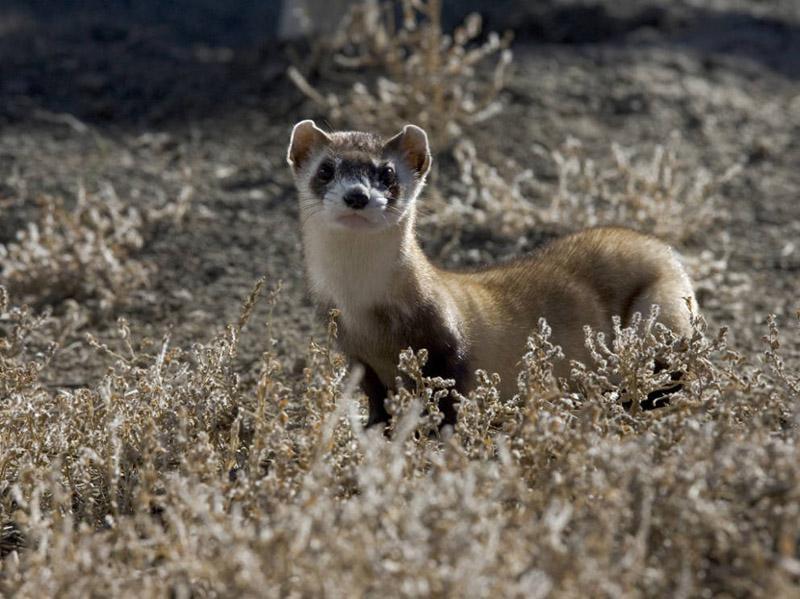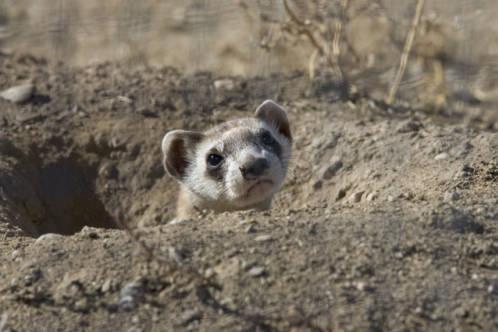The first image is the image on the left, the second image is the image on the right. Given the left and right images, does the statement "All bodies of the animals pictured are facing right." hold true? Answer yes or no. No. The first image is the image on the left, the second image is the image on the right. Analyze the images presented: Is the assertion "One image shows a ferret with raised head, and body turned to the left." valid? Answer yes or no. Yes. 